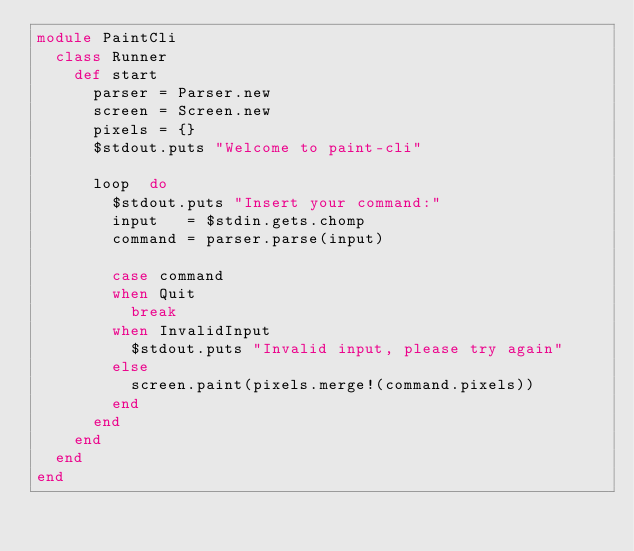<code> <loc_0><loc_0><loc_500><loc_500><_Ruby_>module PaintCli
  class Runner
    def start
      parser = Parser.new
      screen = Screen.new
      pixels = {}
      $stdout.puts "Welcome to paint-cli"

      loop  do
        $stdout.puts "Insert your command:"
        input   = $stdin.gets.chomp
        command = parser.parse(input)

        case command
        when Quit
          break
        when InvalidInput
          $stdout.puts "Invalid input, please try again"
        else
          screen.paint(pixels.merge!(command.pixels))
        end
      end
    end
  end
end
</code> 